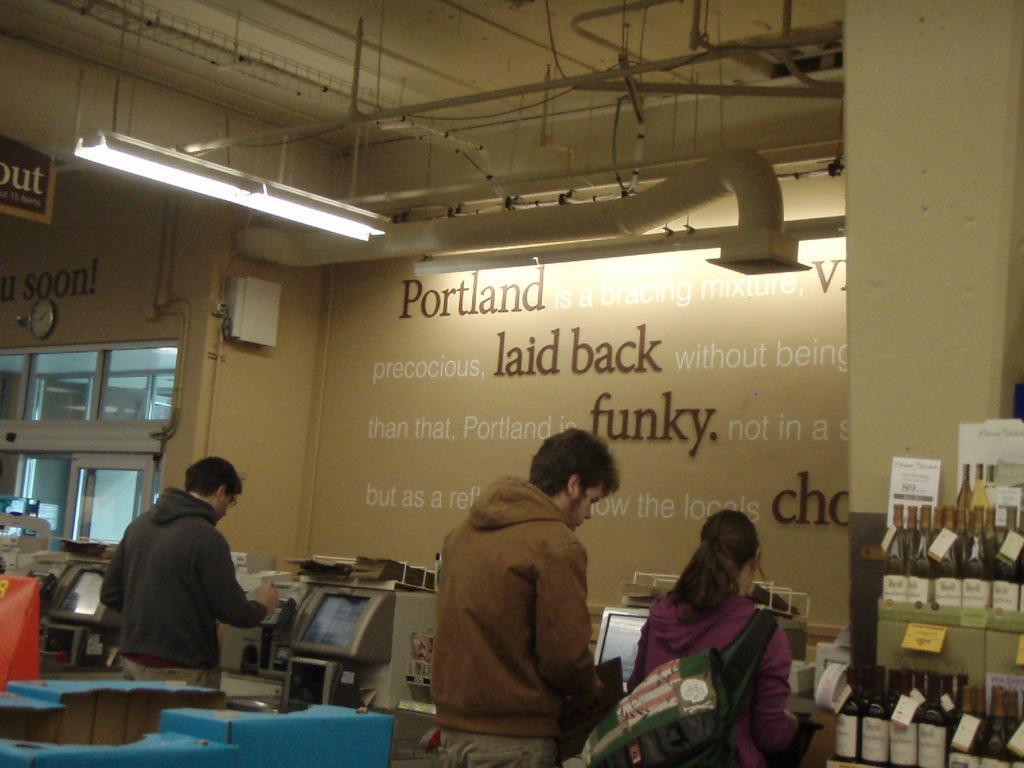Please provide a concise description of this image. In this picture we can see there are three people standing and in front of the people there are some machines. On the right side of the people there are some bottles in and on the racks. Behind the machines there is a wall with some words, windows, a clock and an object. At the top there are pipes, a light and the board. 